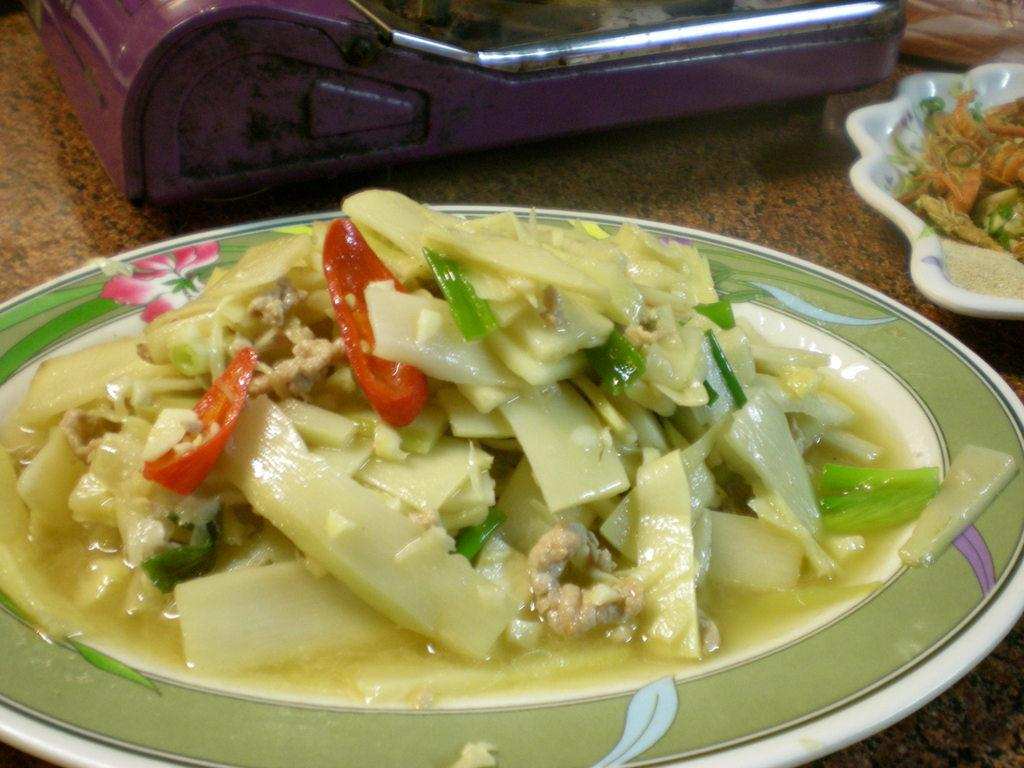What is present on the surface that resembles a table in the image? There is a plate in the image. What is on the plate? There is food on the plate. Can you describe the object towards the top of the image? Unfortunately, the provided facts do not give enough information to describe the object towards the top of the image. How many cacti are visible in the image? There are no cacti present in the image. 